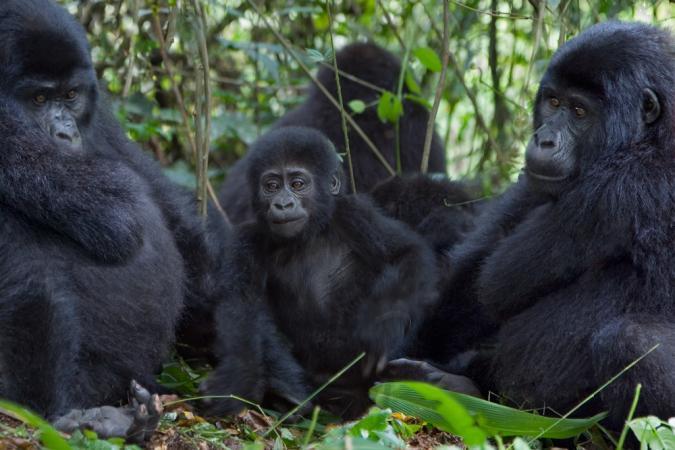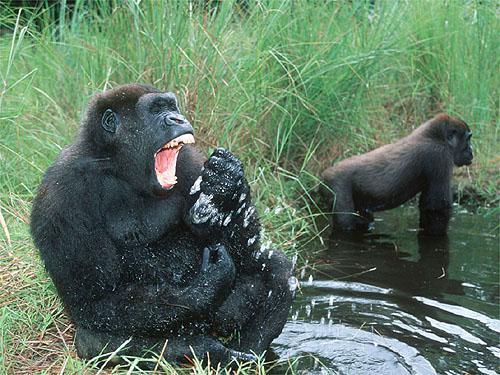The first image is the image on the left, the second image is the image on the right. Assess this claim about the two images: "One of the images contain only one gorrilla.". Correct or not? Answer yes or no. No. The first image is the image on the left, the second image is the image on the right. Examine the images to the left and right. Is the description "One of the images features an adult gorilla carrying a baby gorilla." accurate? Answer yes or no. No. 